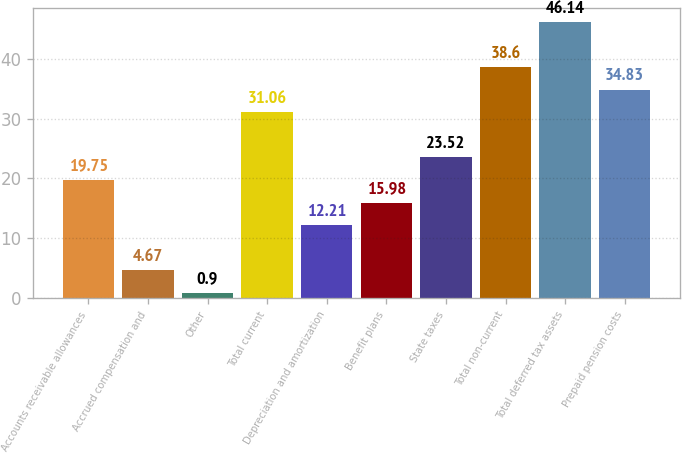<chart> <loc_0><loc_0><loc_500><loc_500><bar_chart><fcel>Accounts receivable allowances<fcel>Accrued compensation and<fcel>Other<fcel>Total current<fcel>Depreciation and amortization<fcel>Benefit plans<fcel>State taxes<fcel>Total non-current<fcel>Total deferred tax assets<fcel>Prepaid pension costs<nl><fcel>19.75<fcel>4.67<fcel>0.9<fcel>31.06<fcel>12.21<fcel>15.98<fcel>23.52<fcel>38.6<fcel>46.14<fcel>34.83<nl></chart> 